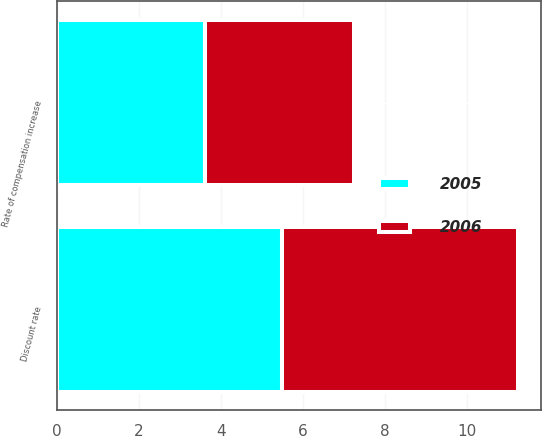<chart> <loc_0><loc_0><loc_500><loc_500><stacked_bar_chart><ecel><fcel>Discount rate<fcel>Rate of compensation increase<nl><fcel>2006<fcel>5.74<fcel>3.63<nl><fcel>2005<fcel>5.49<fcel>3.6<nl></chart> 